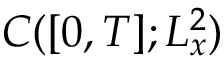Convert formula to latex. <formula><loc_0><loc_0><loc_500><loc_500>C ( [ 0 , T ] ; L _ { x } ^ { 2 } )</formula> 